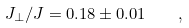<formula> <loc_0><loc_0><loc_500><loc_500>J _ { \perp } / J = 0 . 1 8 \pm 0 . 0 1 \quad ,</formula> 